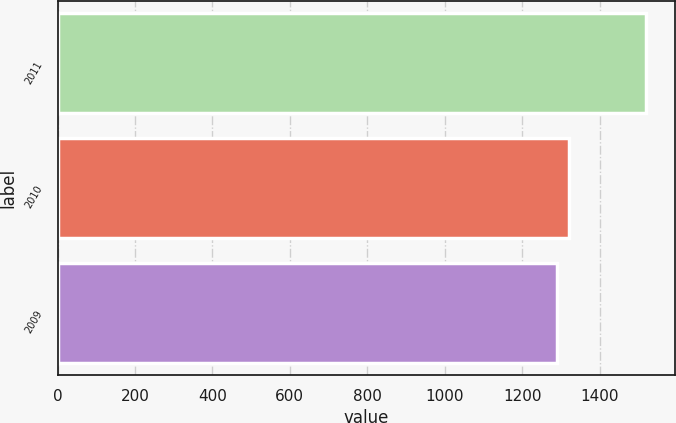Convert chart. <chart><loc_0><loc_0><loc_500><loc_500><bar_chart><fcel>2011<fcel>2010<fcel>2009<nl><fcel>1519<fcel>1322<fcel>1289<nl></chart> 